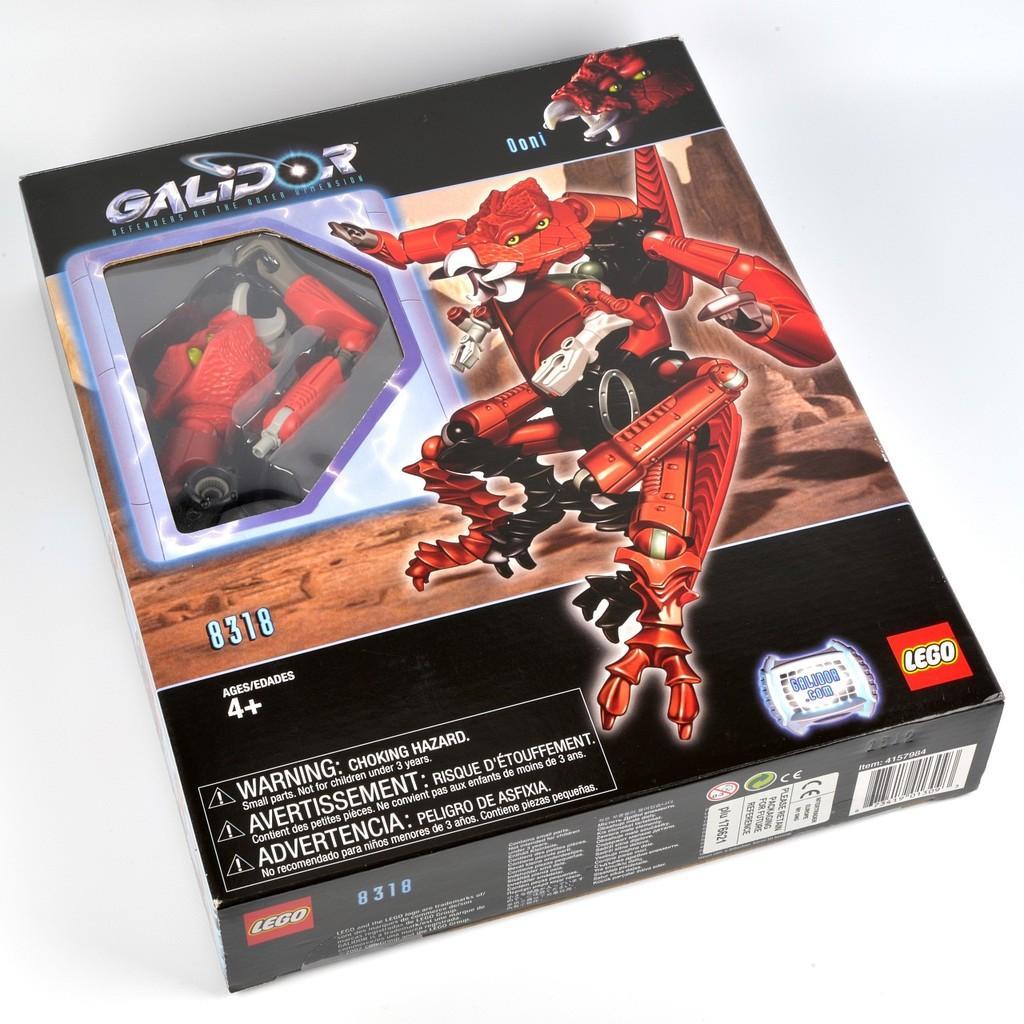Describe this image in one or two sentences. In this image I can see a black colour box and on it I can see something is written. I can also see a red colour cartoon picture on the box and in the background I can see white colour. 